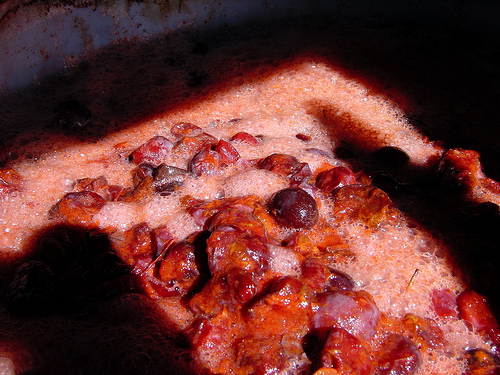<image>
Can you confirm if the grape is on the drink? Yes. Looking at the image, I can see the grape is positioned on top of the drink, with the drink providing support. 